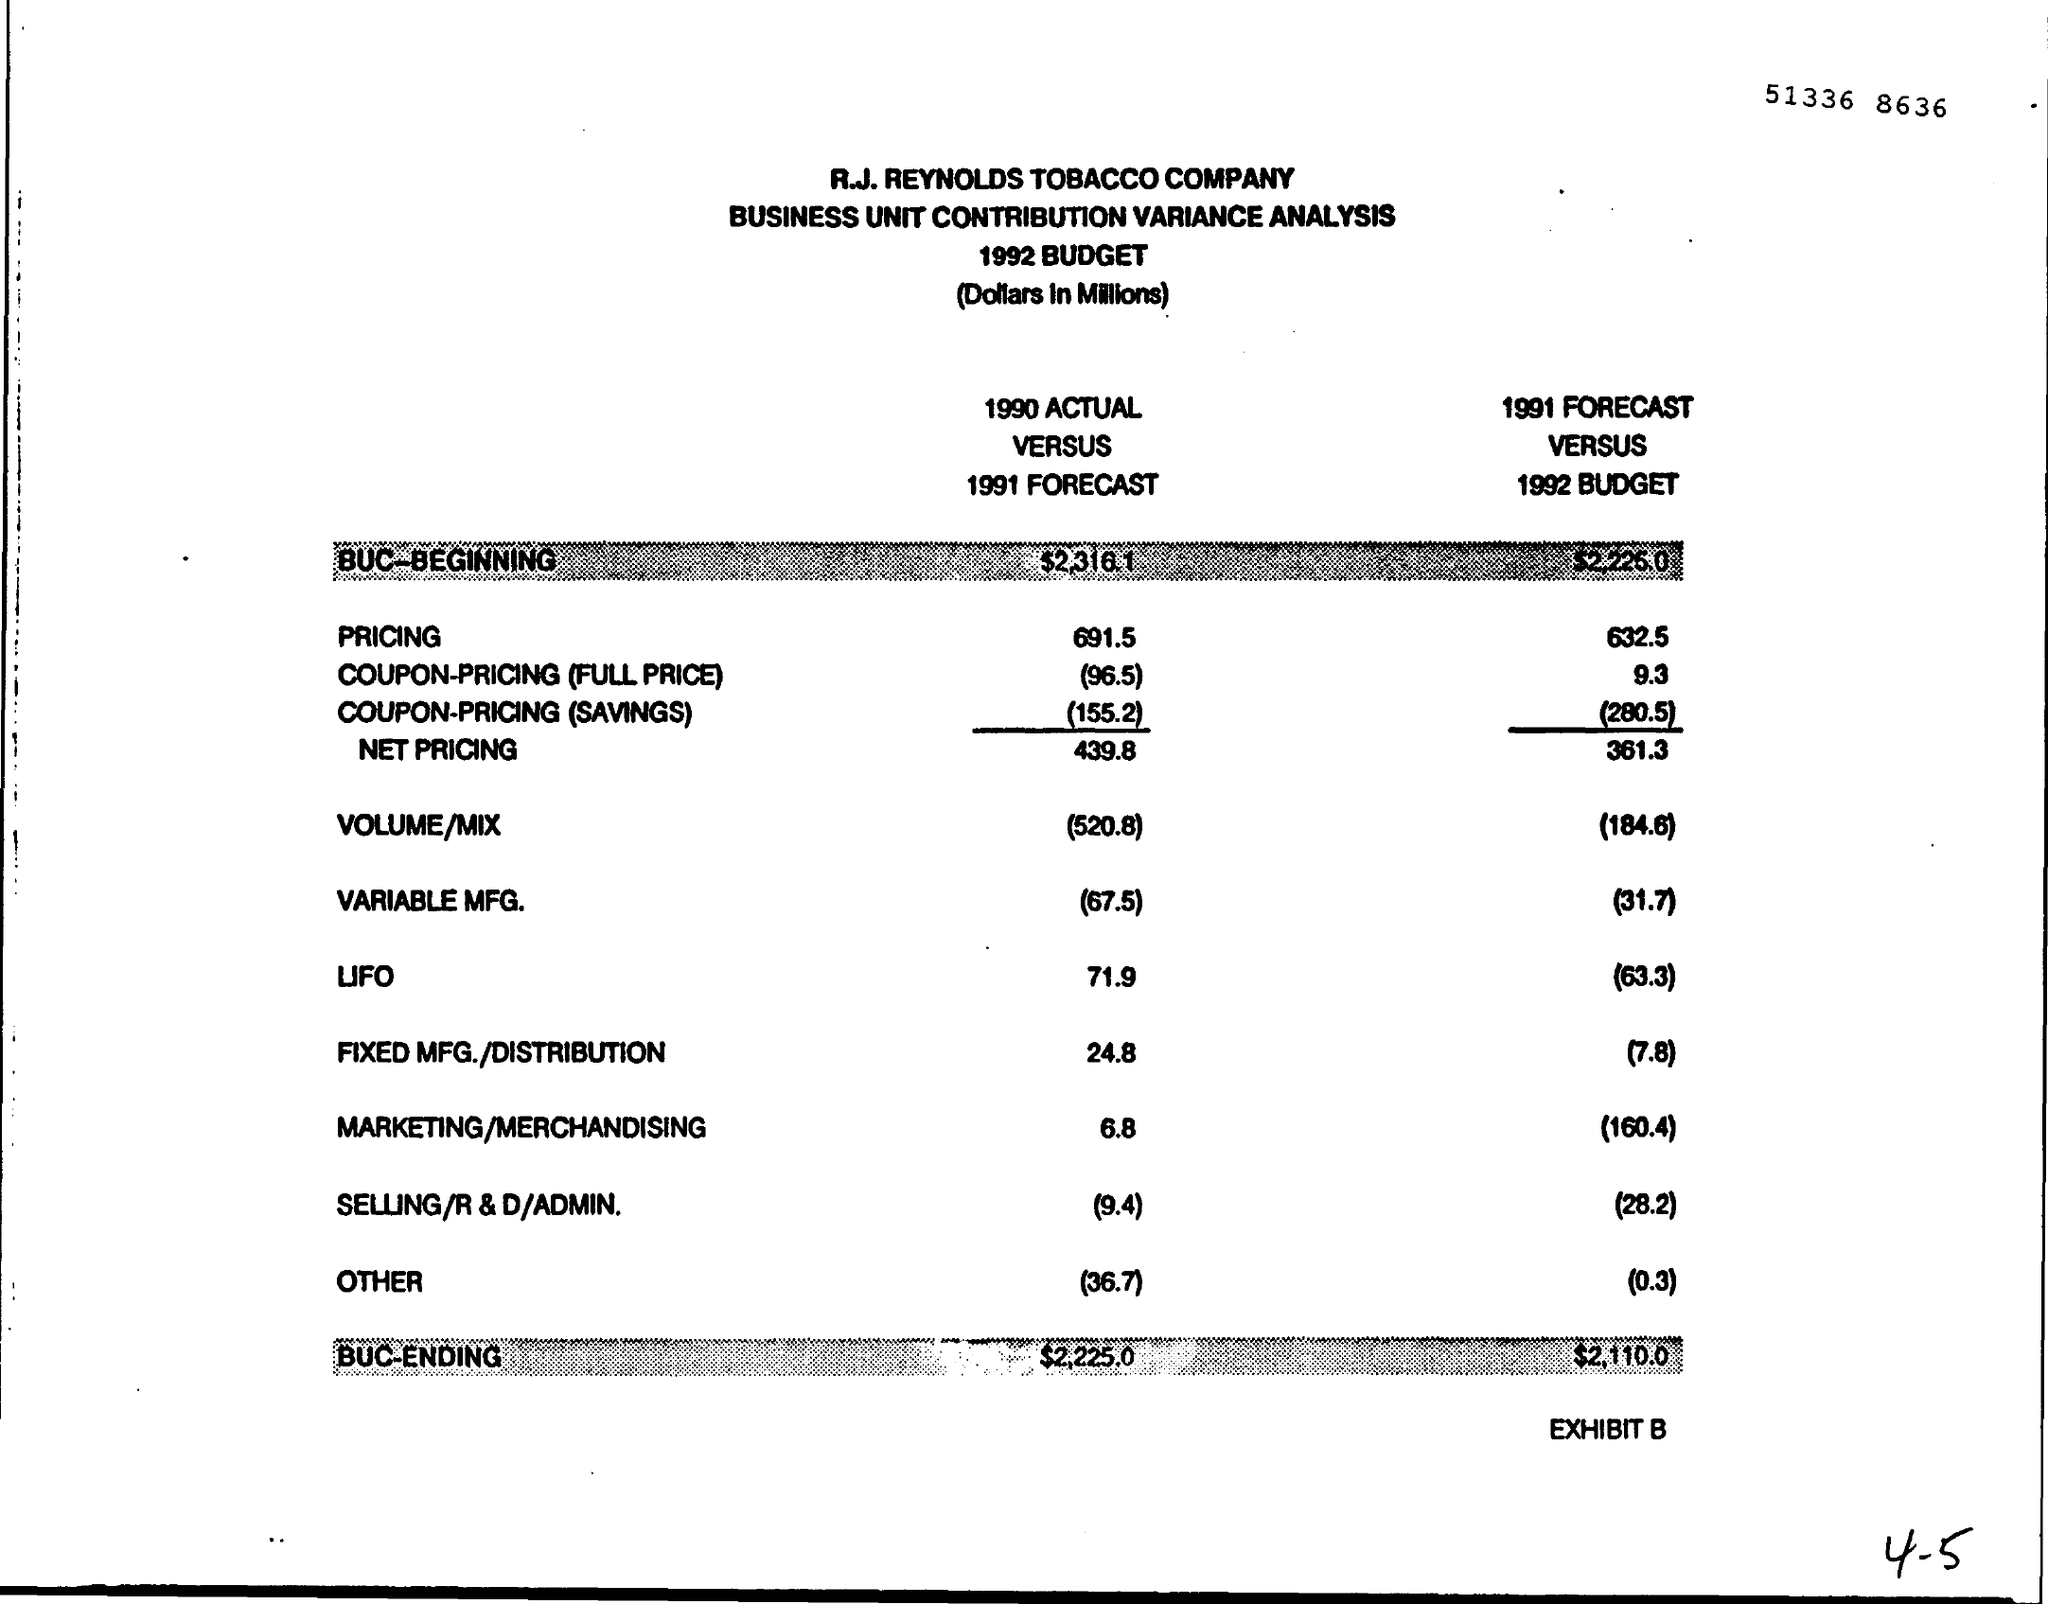Give some essential details in this illustration. The price difference between the actual value of 1990 and the forecasted value of 1991 was 691.5. 